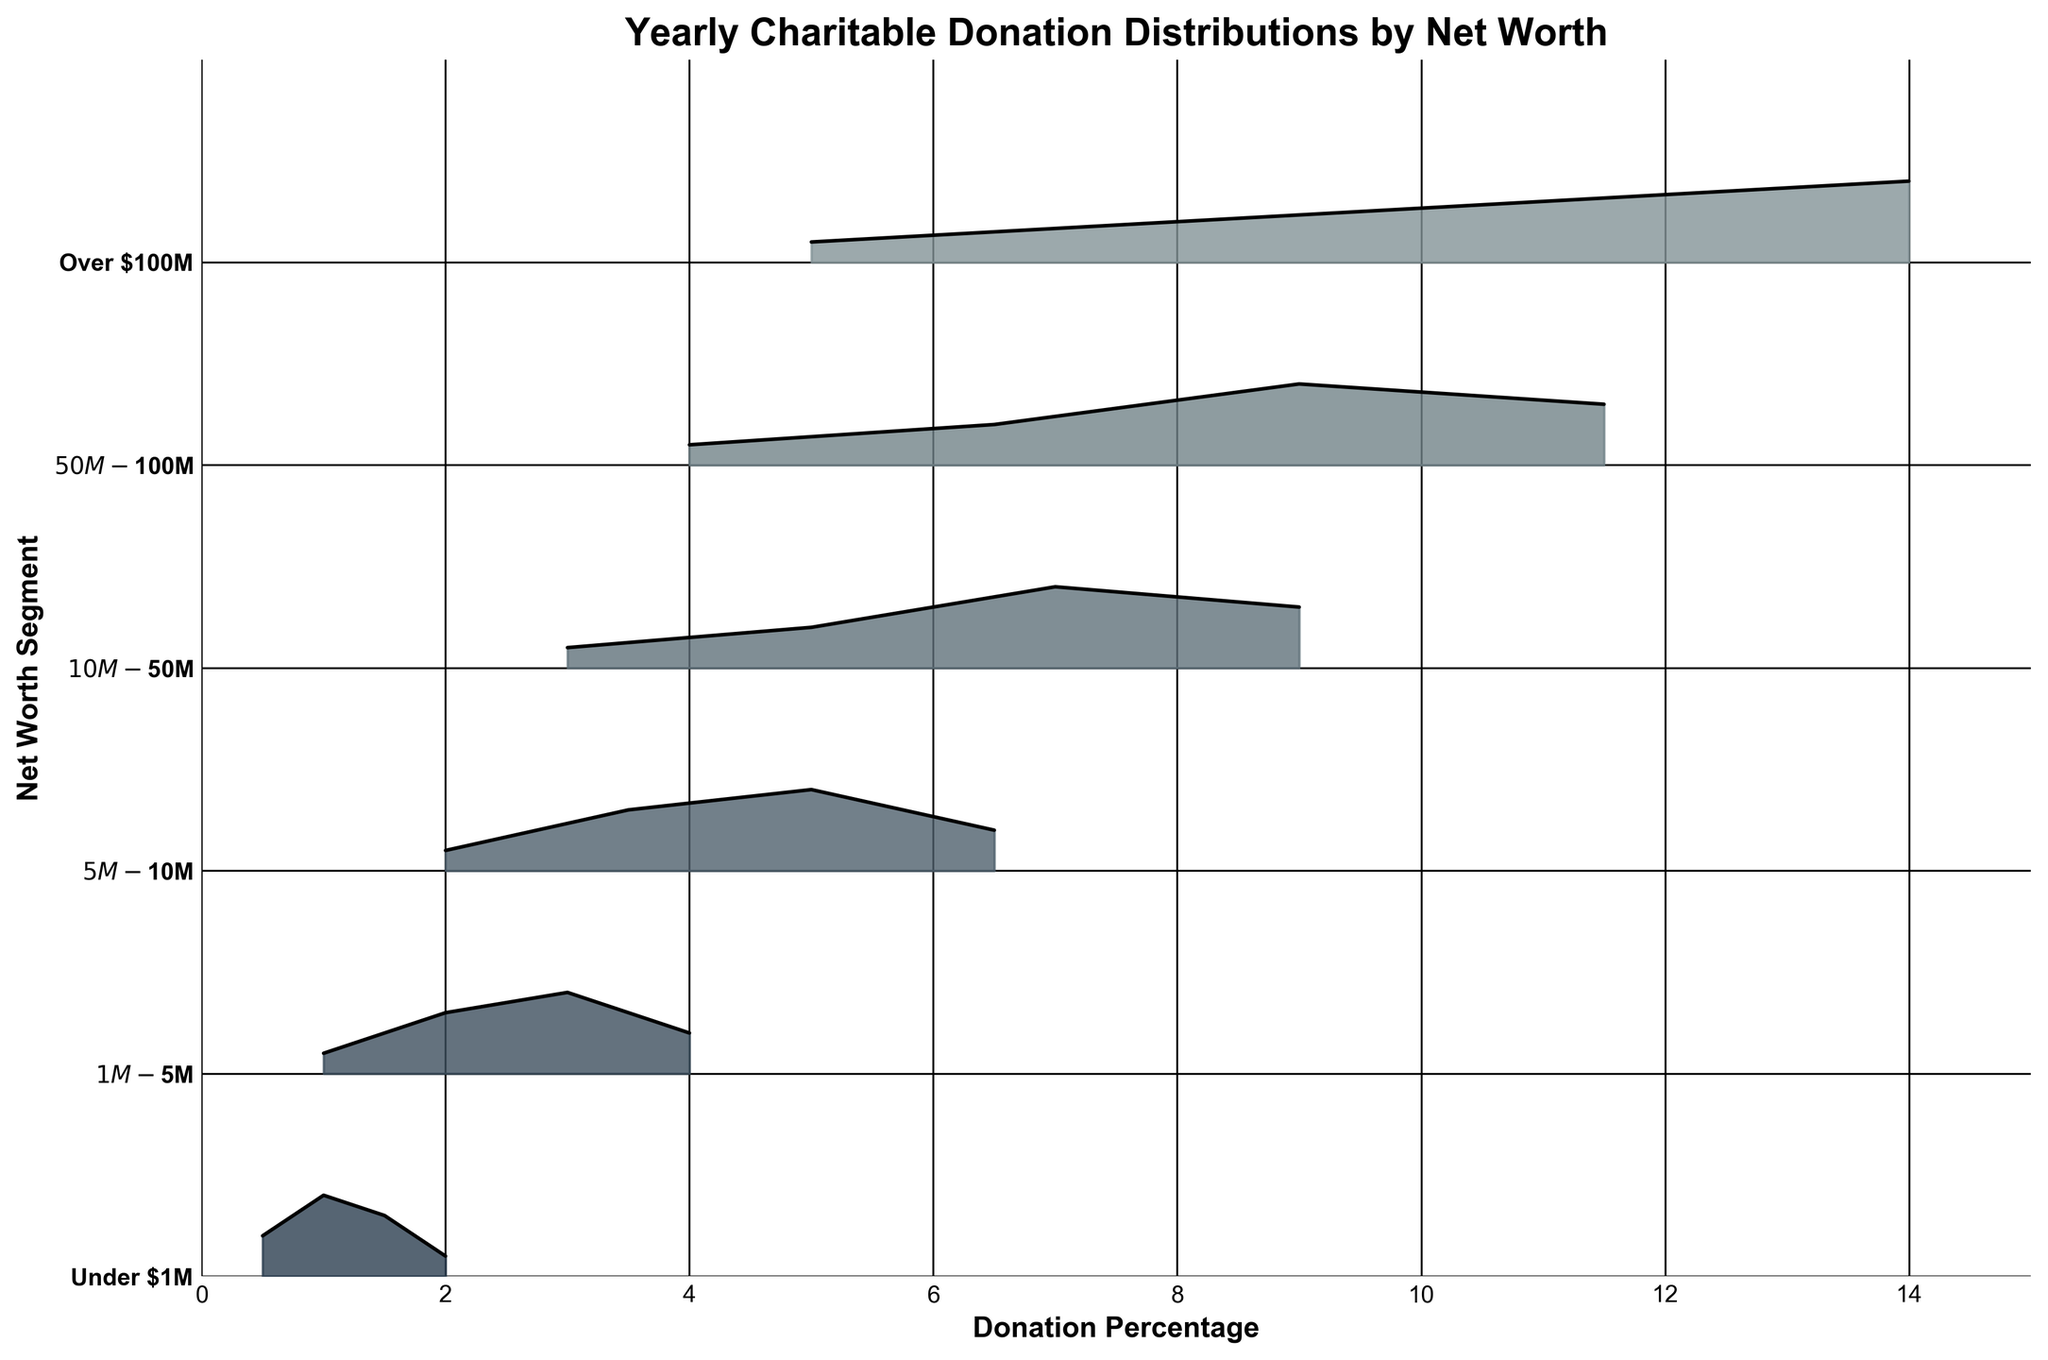What is the title of the figure? The title is located at the top of the figure and it states "Yearly Charitable Donation Distributions by Net Worth".
Answer: Yearly Charitable Donation Distributions by Net Worth What are the net worth segments displayed on the y-axis? The y-axis labels represent different net worth segments. Reading from top to bottom, they are "Under $1M", "$1M-$5M", "$5M-$10M", "$10M-$50M", "$50M-$100M", and "Over $100M".
Answer: Under $1M, $1M-$5M, $5M-$10M, $10M-$50M, $50M-$100M, Over $100M What is the range of the donation percentage displayed on the x-axis? The x-axis represents the donation percentage, ranging from 0 to 15.
Answer: 0 to 15 Which net worth segment has the highest density at the highest donation percentage? The highest donation percentage displayed on the x-axis is 14.0, and the net worth segment "Over $100M" has the highest density at this donation percentage.
Answer: Over $100M Which two net worth segments have a density peak at a donation percentage of 9.0%? Reading across the x-axis at the 9.0 percentage mark, the two net worth segments with density peaks are "$10M-$50M" and "$50M-$100M".
Answer: $10M-$50M, $50M-$100M Which net worth segment's donation distribution peaks at the lowest donation percentage? The lowest donation percentage with a peak is 1.0, found in the "Under $1M" net worth segment.
Answer: Under $1M How many segments have their highest density in the range of 1.0-5.0% donation percentage? Checking each segment's highest density within the given donation percentage range: "Under $1M" peaks at 1.0%, "$1M-$5M" peaks at 3.0%, and "$5M-$10M" peaks at 5.0%. Thus, three segments have their highest density within 1.0-5.0%.
Answer: 3 At what donation percentage do net worth segments meet a density of 0.4? The donation percentages with a density of 0.4 are: "Under $1M" at 1.0%, "$1M-$5M" at 3.0%, "$5M-$10M" at 5.0%, "$10M-$50M" at 7.0%, "$50M-$100M" at 9.0%, and "Over $100M" at 14.0%.
Answer: 1.0%, 3.0%, 5.0%, 7.0%, 9.0%, 14.0% What is the trend in donation percentages as the net worth segments increase? From "Under $1M" to "Over $100M", the donation percentages with the highest density gradually increase, showing a peak at higher donation percentages corresponding to higher net worth.
Answer: Higher net worth leads to higher donation percentages What donation percentage range does the "Over $100M" segment focus on compared to the "Under $1M" segment? The "Over $100M" segment has donations peaking in the 5.0-14.0% range, whereas the "Under $1M" segment peaks in the 0.5-2.0% range.
Answer: 5.0-14.0% vs 0.5-2.0% 